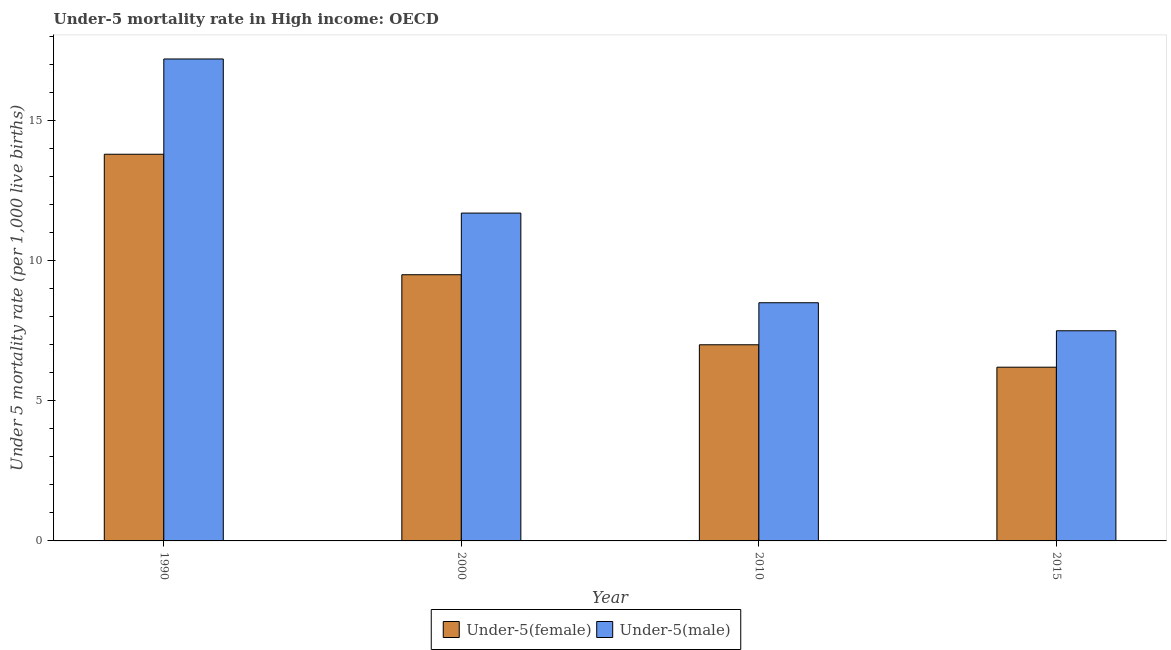How many different coloured bars are there?
Provide a short and direct response. 2. Are the number of bars on each tick of the X-axis equal?
Your response must be concise. Yes. How many bars are there on the 2nd tick from the left?
Your answer should be very brief. 2. Across all years, what is the maximum under-5 male mortality rate?
Ensure brevity in your answer.  17.2. Across all years, what is the minimum under-5 male mortality rate?
Offer a terse response. 7.5. In which year was the under-5 female mortality rate maximum?
Your answer should be compact. 1990. In which year was the under-5 male mortality rate minimum?
Your answer should be compact. 2015. What is the total under-5 female mortality rate in the graph?
Your answer should be compact. 36.5. What is the difference between the under-5 female mortality rate in 2010 and that in 2015?
Offer a very short reply. 0.8. What is the average under-5 female mortality rate per year?
Keep it short and to the point. 9.12. In how many years, is the under-5 female mortality rate greater than 3?
Ensure brevity in your answer.  4. What is the ratio of the under-5 female mortality rate in 2000 to that in 2015?
Offer a very short reply. 1.53. Is the under-5 male mortality rate in 1990 less than that in 2010?
Your answer should be very brief. No. What is the difference between the highest and the second highest under-5 male mortality rate?
Keep it short and to the point. 5.5. What is the difference between the highest and the lowest under-5 female mortality rate?
Offer a very short reply. 7.6. In how many years, is the under-5 male mortality rate greater than the average under-5 male mortality rate taken over all years?
Offer a very short reply. 2. Is the sum of the under-5 female mortality rate in 2000 and 2010 greater than the maximum under-5 male mortality rate across all years?
Offer a very short reply. Yes. What does the 2nd bar from the left in 2000 represents?
Your answer should be compact. Under-5(male). What does the 1st bar from the right in 1990 represents?
Provide a succinct answer. Under-5(male). How many bars are there?
Offer a terse response. 8. Are all the bars in the graph horizontal?
Your response must be concise. No. How many years are there in the graph?
Offer a terse response. 4. How many legend labels are there?
Your response must be concise. 2. How are the legend labels stacked?
Keep it short and to the point. Horizontal. What is the title of the graph?
Provide a short and direct response. Under-5 mortality rate in High income: OECD. What is the label or title of the Y-axis?
Ensure brevity in your answer.  Under 5 mortality rate (per 1,0 live births). What is the Under 5 mortality rate (per 1,000 live births) in Under-5(female) in 1990?
Your answer should be compact. 13.8. What is the Under 5 mortality rate (per 1,000 live births) of Under-5(male) in 1990?
Make the answer very short. 17.2. What is the Under 5 mortality rate (per 1,000 live births) of Under-5(female) in 2000?
Offer a very short reply. 9.5. What is the Under 5 mortality rate (per 1,000 live births) of Under-5(male) in 2000?
Offer a very short reply. 11.7. What is the Under 5 mortality rate (per 1,000 live births) in Under-5(female) in 2010?
Give a very brief answer. 7. Across all years, what is the maximum Under 5 mortality rate (per 1,000 live births) of Under-5(female)?
Provide a short and direct response. 13.8. Across all years, what is the minimum Under 5 mortality rate (per 1,000 live births) of Under-5(female)?
Make the answer very short. 6.2. What is the total Under 5 mortality rate (per 1,000 live births) of Under-5(female) in the graph?
Provide a succinct answer. 36.5. What is the total Under 5 mortality rate (per 1,000 live births) of Under-5(male) in the graph?
Give a very brief answer. 44.9. What is the difference between the Under 5 mortality rate (per 1,000 live births) of Under-5(female) in 1990 and that in 2000?
Provide a short and direct response. 4.3. What is the difference between the Under 5 mortality rate (per 1,000 live births) in Under-5(female) in 1990 and that in 2010?
Make the answer very short. 6.8. What is the difference between the Under 5 mortality rate (per 1,000 live births) in Under-5(male) in 1990 and that in 2010?
Ensure brevity in your answer.  8.7. What is the difference between the Under 5 mortality rate (per 1,000 live births) of Under-5(female) in 1990 and that in 2015?
Provide a short and direct response. 7.6. What is the difference between the Under 5 mortality rate (per 1,000 live births) in Under-5(male) in 1990 and that in 2015?
Ensure brevity in your answer.  9.7. What is the difference between the Under 5 mortality rate (per 1,000 live births) in Under-5(female) in 2000 and that in 2010?
Your answer should be very brief. 2.5. What is the difference between the Under 5 mortality rate (per 1,000 live births) in Under-5(female) in 2000 and that in 2015?
Ensure brevity in your answer.  3.3. What is the difference between the Under 5 mortality rate (per 1,000 live births) of Under-5(male) in 2000 and that in 2015?
Offer a very short reply. 4.2. What is the difference between the Under 5 mortality rate (per 1,000 live births) of Under-5(female) in 2010 and that in 2015?
Offer a terse response. 0.8. What is the difference between the Under 5 mortality rate (per 1,000 live births) of Under-5(male) in 2010 and that in 2015?
Offer a terse response. 1. What is the difference between the Under 5 mortality rate (per 1,000 live births) in Under-5(female) in 1990 and the Under 5 mortality rate (per 1,000 live births) in Under-5(male) in 2000?
Ensure brevity in your answer.  2.1. What is the difference between the Under 5 mortality rate (per 1,000 live births) of Under-5(female) in 1990 and the Under 5 mortality rate (per 1,000 live births) of Under-5(male) in 2010?
Provide a short and direct response. 5.3. What is the difference between the Under 5 mortality rate (per 1,000 live births) of Under-5(female) in 2010 and the Under 5 mortality rate (per 1,000 live births) of Under-5(male) in 2015?
Ensure brevity in your answer.  -0.5. What is the average Under 5 mortality rate (per 1,000 live births) of Under-5(female) per year?
Provide a succinct answer. 9.12. What is the average Under 5 mortality rate (per 1,000 live births) of Under-5(male) per year?
Your response must be concise. 11.22. In the year 1990, what is the difference between the Under 5 mortality rate (per 1,000 live births) in Under-5(female) and Under 5 mortality rate (per 1,000 live births) in Under-5(male)?
Provide a succinct answer. -3.4. In the year 2015, what is the difference between the Under 5 mortality rate (per 1,000 live births) in Under-5(female) and Under 5 mortality rate (per 1,000 live births) in Under-5(male)?
Offer a terse response. -1.3. What is the ratio of the Under 5 mortality rate (per 1,000 live births) in Under-5(female) in 1990 to that in 2000?
Make the answer very short. 1.45. What is the ratio of the Under 5 mortality rate (per 1,000 live births) in Under-5(male) in 1990 to that in 2000?
Give a very brief answer. 1.47. What is the ratio of the Under 5 mortality rate (per 1,000 live births) of Under-5(female) in 1990 to that in 2010?
Ensure brevity in your answer.  1.97. What is the ratio of the Under 5 mortality rate (per 1,000 live births) of Under-5(male) in 1990 to that in 2010?
Keep it short and to the point. 2.02. What is the ratio of the Under 5 mortality rate (per 1,000 live births) of Under-5(female) in 1990 to that in 2015?
Make the answer very short. 2.23. What is the ratio of the Under 5 mortality rate (per 1,000 live births) in Under-5(male) in 1990 to that in 2015?
Your response must be concise. 2.29. What is the ratio of the Under 5 mortality rate (per 1,000 live births) of Under-5(female) in 2000 to that in 2010?
Provide a short and direct response. 1.36. What is the ratio of the Under 5 mortality rate (per 1,000 live births) of Under-5(male) in 2000 to that in 2010?
Your answer should be compact. 1.38. What is the ratio of the Under 5 mortality rate (per 1,000 live births) in Under-5(female) in 2000 to that in 2015?
Offer a terse response. 1.53. What is the ratio of the Under 5 mortality rate (per 1,000 live births) of Under-5(male) in 2000 to that in 2015?
Give a very brief answer. 1.56. What is the ratio of the Under 5 mortality rate (per 1,000 live births) in Under-5(female) in 2010 to that in 2015?
Ensure brevity in your answer.  1.13. What is the ratio of the Under 5 mortality rate (per 1,000 live births) of Under-5(male) in 2010 to that in 2015?
Provide a short and direct response. 1.13. What is the difference between the highest and the second highest Under 5 mortality rate (per 1,000 live births) of Under-5(female)?
Your answer should be compact. 4.3. What is the difference between the highest and the lowest Under 5 mortality rate (per 1,000 live births) in Under-5(female)?
Your answer should be very brief. 7.6. What is the difference between the highest and the lowest Under 5 mortality rate (per 1,000 live births) of Under-5(male)?
Provide a short and direct response. 9.7. 